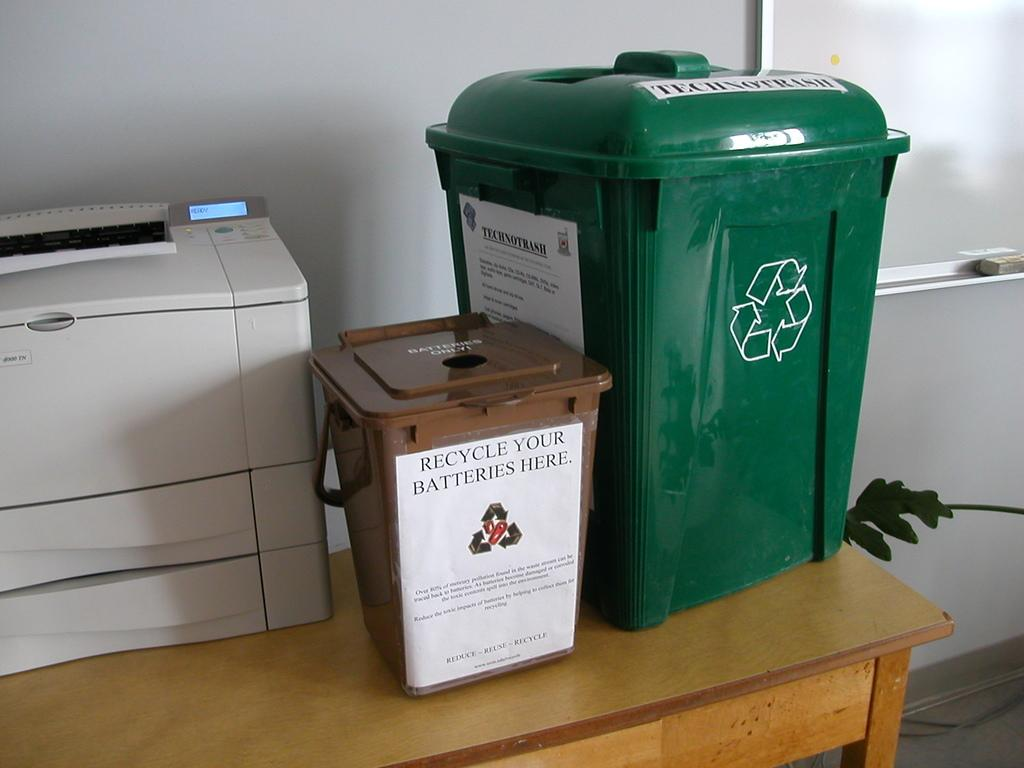<image>
Offer a succinct explanation of the picture presented. Green garbage can next to a brown can that says "Recycle your batteries here". 